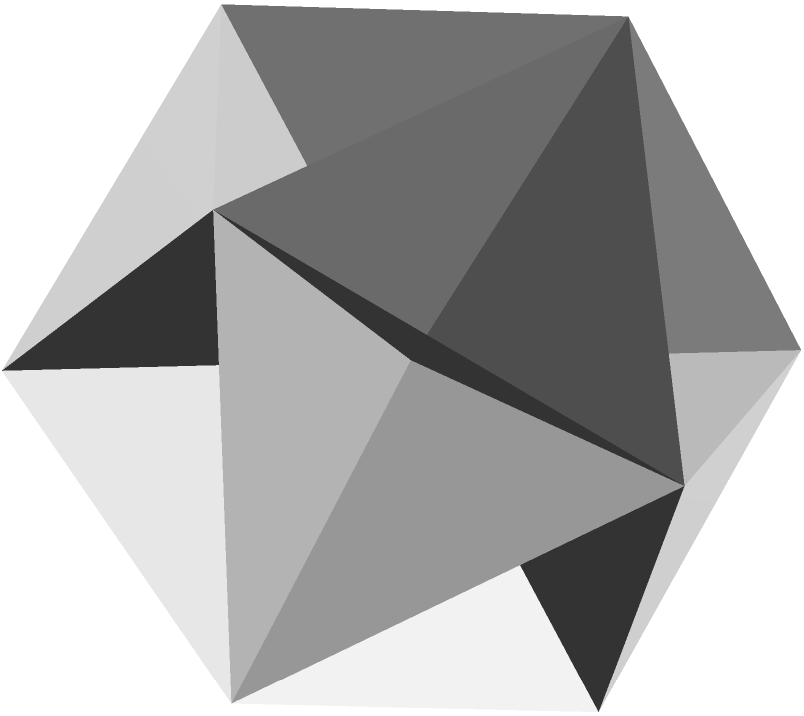As a fellow Nobel laureate, you're undoubtedly familiar with the elegant symmetries found in nature. Consider a regular icosahedron, a Platonic solid with 20 equilateral triangular faces, as shown in the figure. Given that the edge length of this icosahedron is $a$, derive an expression for its total surface area in terms of $a$. How does this relate to the golden ratio, $\phi = \frac{1+\sqrt{5}}{2}$? Let's approach this step-by-step:

1) A regular icosahedron has 20 congruent equilateral triangular faces.

2) The surface area will be 20 times the area of one equilateral triangle.

3) For an equilateral triangle with side length $a$, the area is given by:

   $$A_{triangle} = \frac{\sqrt{3}}{4}a^2$$

4) Therefore, the total surface area of the icosahedron is:

   $$A_{total} = 20 \cdot \frac{\sqrt{3}}{4}a^2 = 5\sqrt{3}a^2$$

5) Now, let's relate this to the golden ratio $\phi$. In an icosahedron:
   - The ratio of the distance between parallel faces to the edge length is $\phi$.
   - The ratio of the length of a face diagonal to the edge length is also $\phi$.

6) While not directly visible in the surface area formula, the golden ratio is inherent in the icosahedron's structure. The dihedral angle between faces is:

   $$\cos^{-1}\left(-\frac{1}{\phi}\right) \approx 138.19°$$

7) The surface area can be related to the volume of the icosahedron, which is:

   $$V = \frac{5(3+\sqrt{5})}{12}a^3 = \frac{5(3+\sqrt{5})}{12}a^3 = \frac{5(3+2\phi-1)}{12}a^3 = \frac{5(2+2\phi)}{12}a^3$$

This elegant relationship between the surface area, volume, and the golden ratio showcases the profound symmetry and beauty inherent in this Platonic solid, reminiscent of the fundamental symmetries we often encounter in our scientific endeavors.
Answer: $5\sqrt{3}a^2$ 